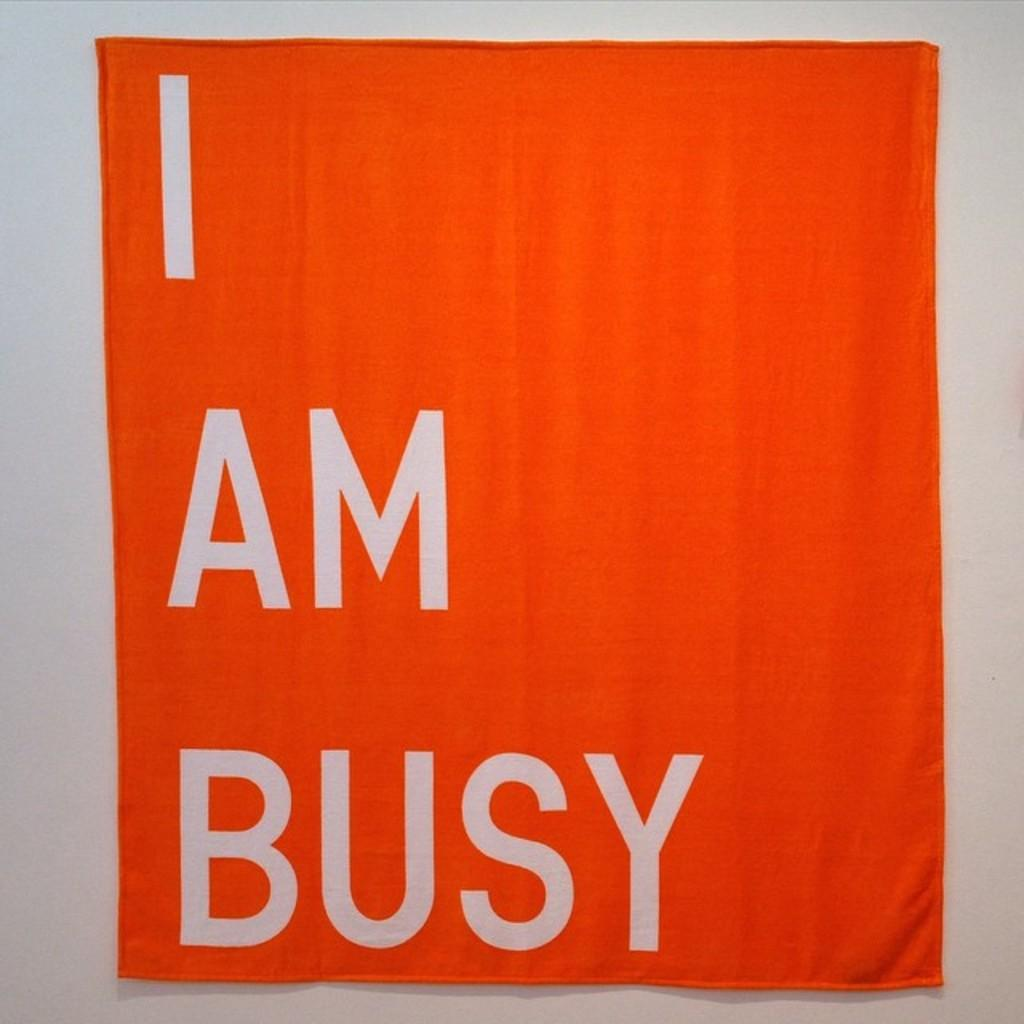Provide a one-sentence caption for the provided image. An orange and white sign that says I am Busy on it hangs on a wall. 